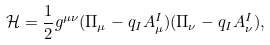Convert formula to latex. <formula><loc_0><loc_0><loc_500><loc_500>\mathcal { H } = \frac { 1 } { 2 } g ^ { \mu \nu } ( \Pi _ { \mu } - q _ { I } A ^ { I } _ { \mu } ) ( \Pi _ { \nu } - q _ { I } A ^ { I } _ { \nu } ) ,</formula> 